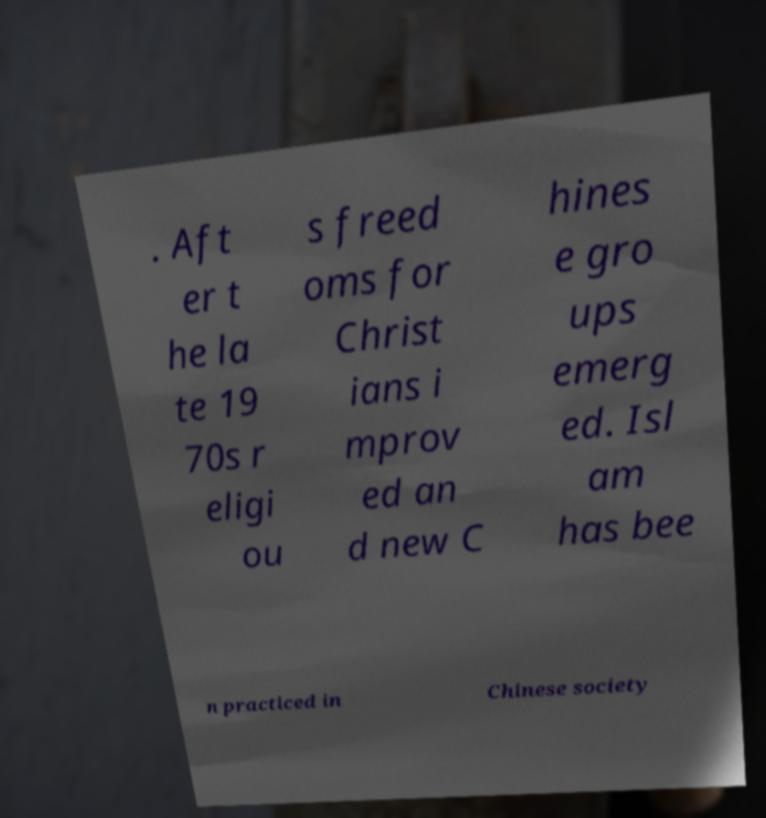There's text embedded in this image that I need extracted. Can you transcribe it verbatim? . Aft er t he la te 19 70s r eligi ou s freed oms for Christ ians i mprov ed an d new C hines e gro ups emerg ed. Isl am has bee n practiced in Chinese society 